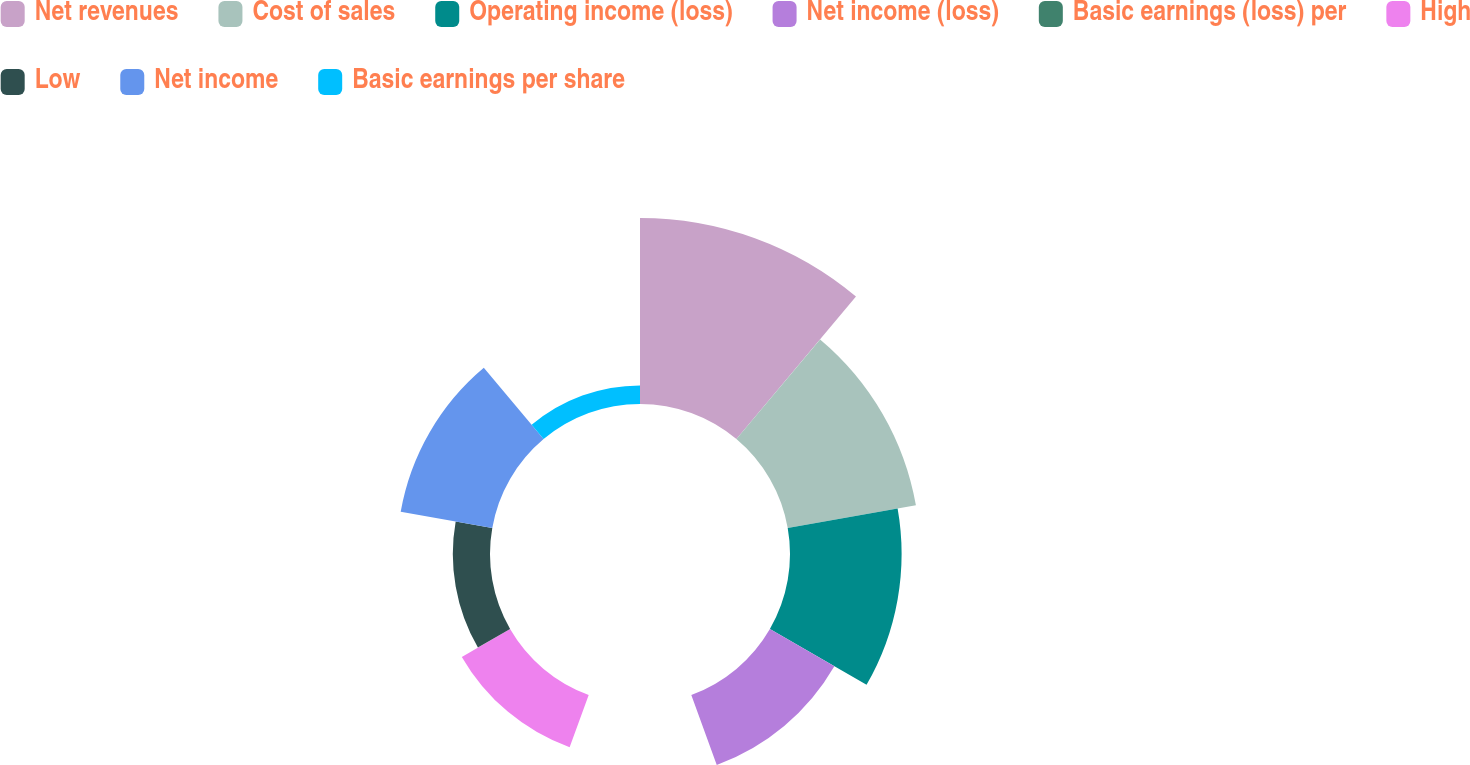Convert chart to OTSL. <chart><loc_0><loc_0><loc_500><loc_500><pie_chart><fcel>Net revenues<fcel>Cost of sales<fcel>Operating income (loss)<fcel>Net income (loss)<fcel>Basic earnings (loss) per<fcel>High<fcel>Low<fcel>Net income<fcel>Basic earnings per share<nl><fcel>26.32%<fcel>18.42%<fcel>15.79%<fcel>10.53%<fcel>0.0%<fcel>7.89%<fcel>5.26%<fcel>13.16%<fcel>2.63%<nl></chart> 